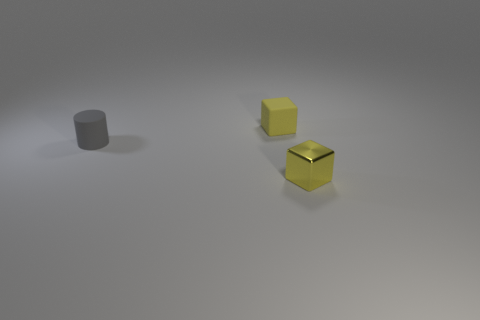There is a shiny block; is its color the same as the object behind the matte cylinder?
Make the answer very short. Yes. Are there any brown rubber things of the same size as the gray matte cylinder?
Ensure brevity in your answer.  No. What is the size of the other cube that is the same color as the small metal cube?
Your response must be concise. Small. There is a yellow cube on the right side of the yellow rubber block; what is its material?
Offer a very short reply. Metal. Are there an equal number of gray things to the left of the rubber cylinder and yellow metal things that are to the right of the tiny yellow metal object?
Give a very brief answer. Yes. Do the block left of the metallic cube and the yellow block in front of the tiny cylinder have the same size?
Provide a short and direct response. Yes. How many other small objects have the same color as the shiny thing?
Ensure brevity in your answer.  1. What is the material of the tiny object that is the same color as the metallic cube?
Provide a succinct answer. Rubber. Are there more tiny objects that are behind the gray object than matte cylinders?
Your answer should be very brief. No. Is the gray rubber object the same shape as the tiny yellow rubber thing?
Offer a terse response. No. 